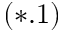Convert formula to latex. <formula><loc_0><loc_0><loc_500><loc_500>( * . 1 )</formula> 